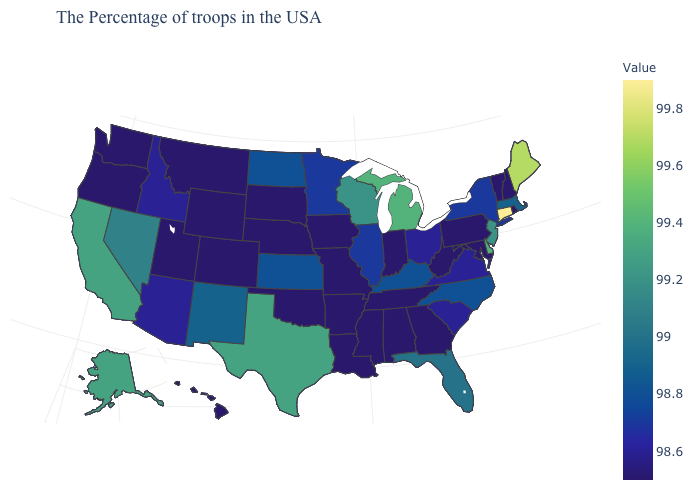Is the legend a continuous bar?
Keep it brief. Yes. Does Utah have a lower value than Kentucky?
Answer briefly. Yes. Does Connecticut have the highest value in the USA?
Concise answer only. Yes. Does Louisiana have a lower value than Kentucky?
Answer briefly. Yes. Does Ohio have the lowest value in the MidWest?
Be succinct. No. Is the legend a continuous bar?
Quick response, please. Yes. Among the states that border North Dakota , does Minnesota have the lowest value?
Short answer required. No. Which states have the lowest value in the MidWest?
Answer briefly. Indiana, Missouri, Iowa, Nebraska, South Dakota. 